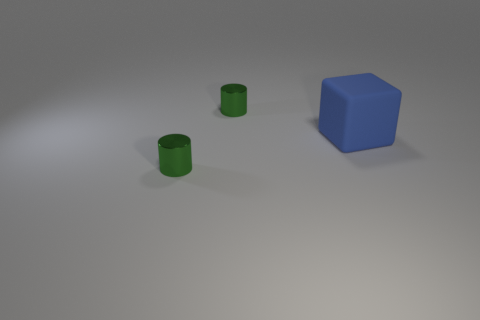Add 3 blue things. How many objects exist? 6 Subtract all cylinders. How many objects are left? 1 Add 2 green matte blocks. How many green matte blocks exist? 2 Subtract 0 yellow blocks. How many objects are left? 3 Subtract all big blue things. Subtract all large yellow rubber spheres. How many objects are left? 2 Add 2 large blue blocks. How many large blue blocks are left? 3 